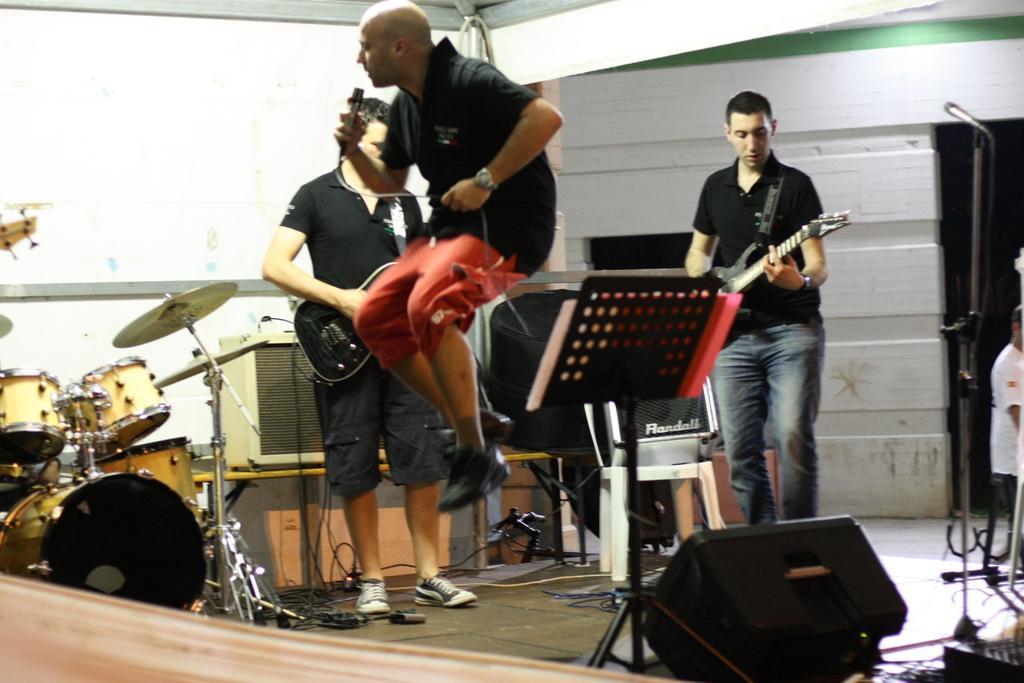Please provide a concise description of this image. A person wearing black and red dress is holding a mic singing and jumping. In the back a person is holding a guitar and playing. Also in the other side another person is holding a guitar and playing. There is mic stand. There are speakers. In the left end there is a drums and cymbal. In the background there is a wall. 